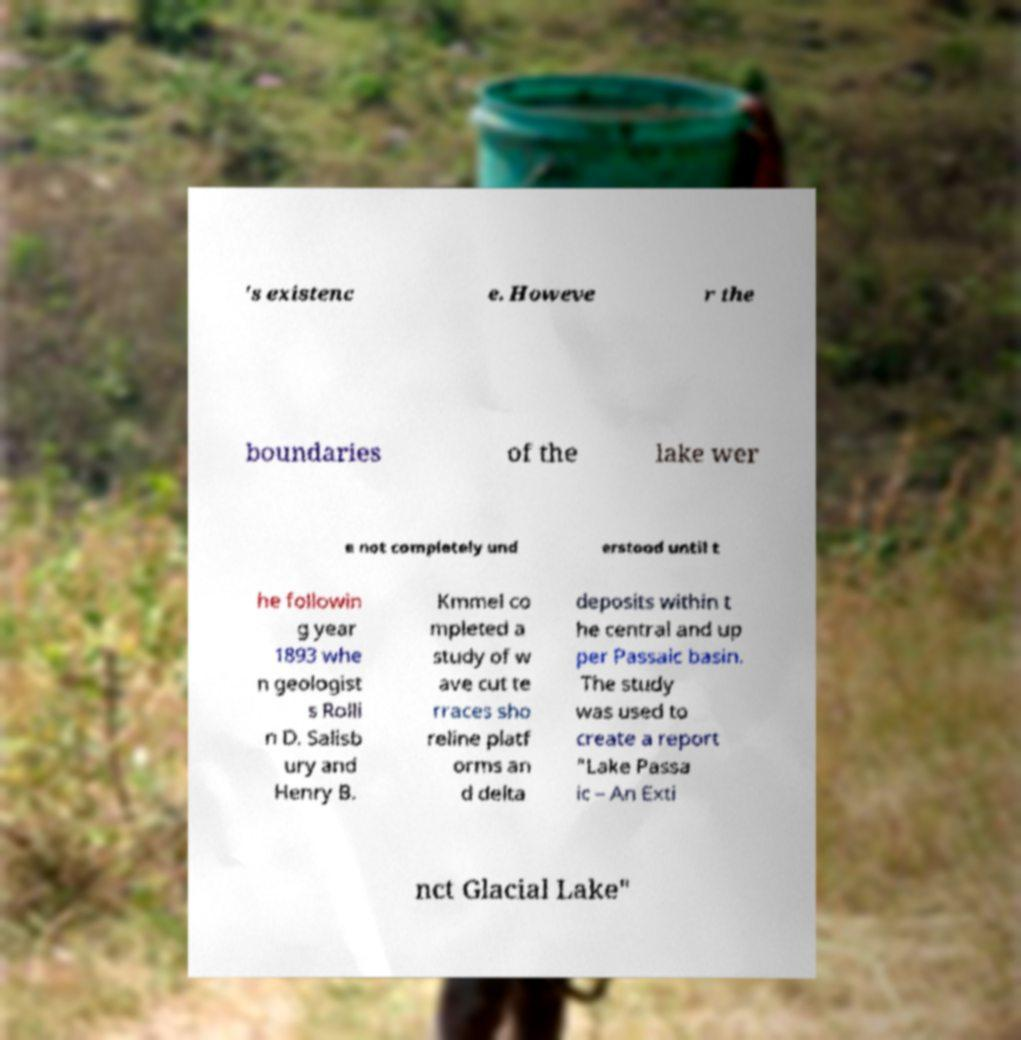For documentation purposes, I need the text within this image transcribed. Could you provide that? 's existenc e. Howeve r the boundaries of the lake wer e not completely und erstood until t he followin g year 1893 whe n geologist s Rolli n D. Salisb ury and Henry B. Kmmel co mpleted a study of w ave cut te rraces sho reline platf orms an d delta deposits within t he central and up per Passaic basin. The study was used to create a report "Lake Passa ic – An Exti nct Glacial Lake" 